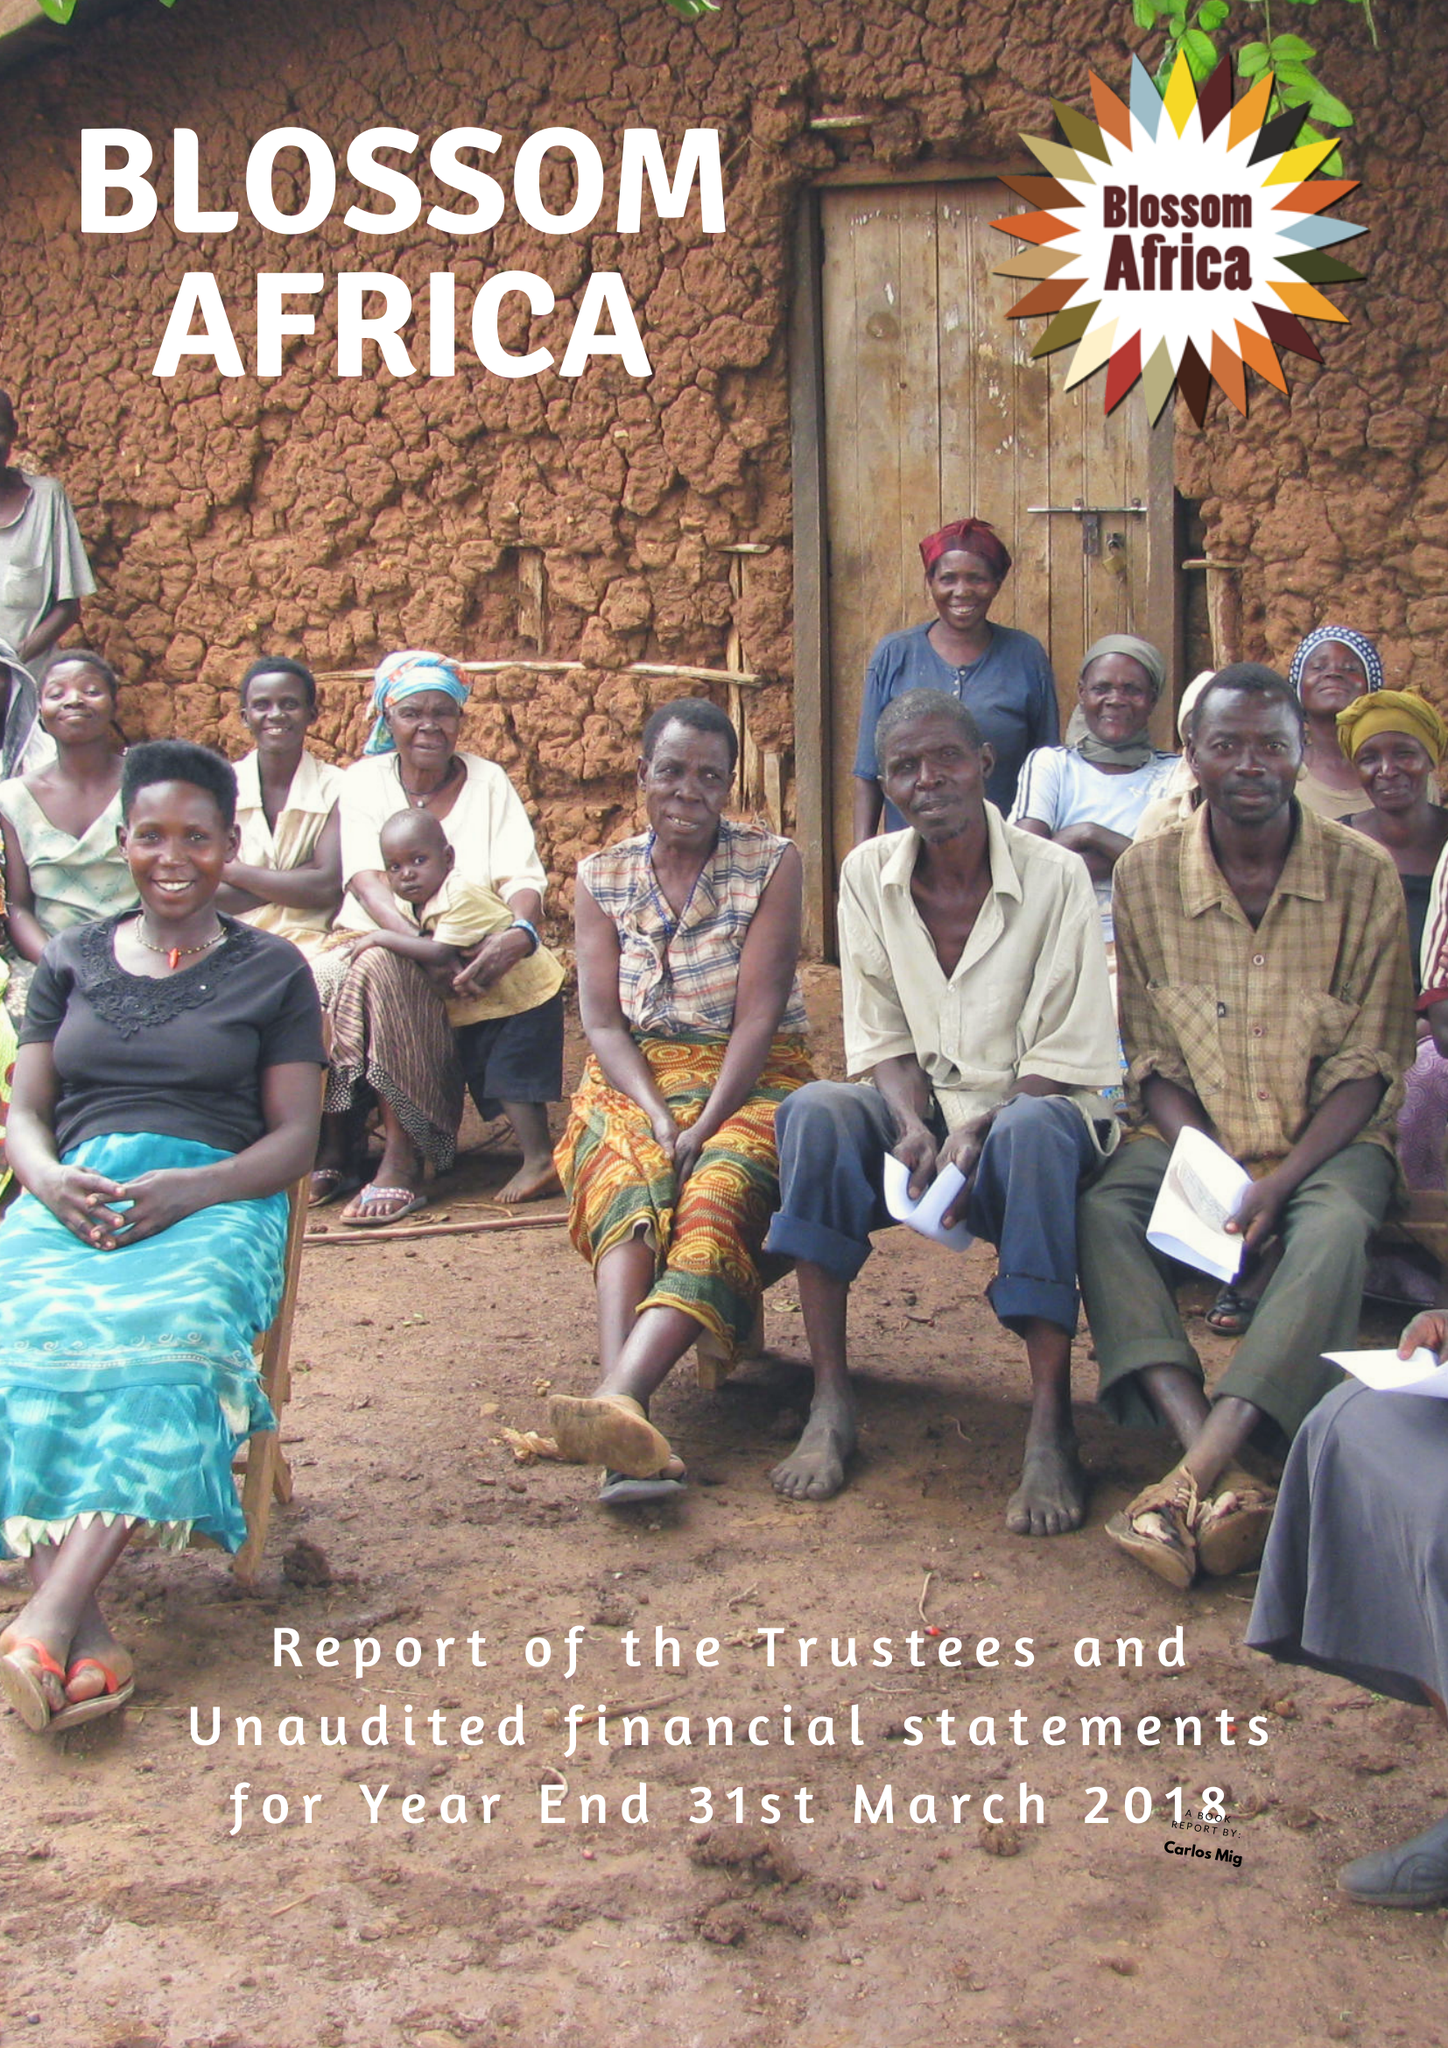What is the value for the address__street_line?
Answer the question using a single word or phrase. 1 STATION APPROACH 